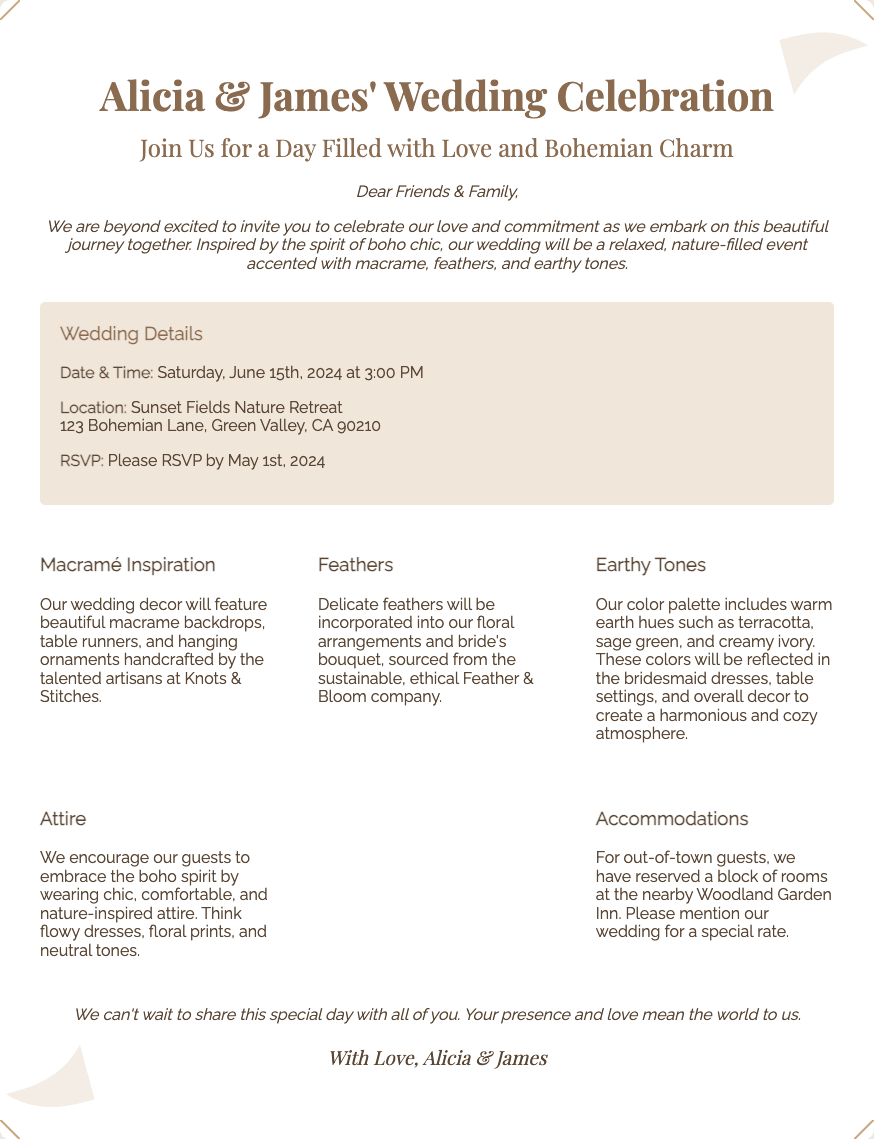What is the date of the wedding? The date of the wedding is specified in the document as Saturday, June 15th, 2024.
Answer: June 15th, 2024 Where is the wedding taking place? The location of the wedding is provided as Sunset Fields Nature Retreat, 123 Bohemian Lane, Green Valley, CA 90210.
Answer: Sunset Fields Nature Retreat What should guests wear? The attire recommendation encourages guests to wear chic, comfortable, and nature-inspired attire.
Answer: Boho spirit attire What are the colors of the wedding? The color palette is mentioned as warm earth hues including terracotta, sage green, and creamy ivory.
Answer: Terracotta, sage green, creamy ivory Who are the couple getting married? The names of the couple getting married are mentioned at the start of the invitation.
Answer: Alicia & James When is the RSVP deadline? The deadline for RSVPs is stated as May 1st, 2024.
Answer: May 1st, 2024 What decorative elements are featured at the wedding? The document highlights macrame, feathers, and earthy tones as the main decorative elements.
Answer: Macrame, feathers, earthy tones Which company is mentioned for sourcing feathers? The name of the company that provides feathers is mentioned in the wedding details.
Answer: Feather & Bloom What kind of atmosphere does the couple want to create? The atmosphere is described as harmonious and cozy through the use of colors and decorations.
Answer: Harmonious and cozy atmosphere 